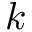<formula> <loc_0><loc_0><loc_500><loc_500>k</formula> 